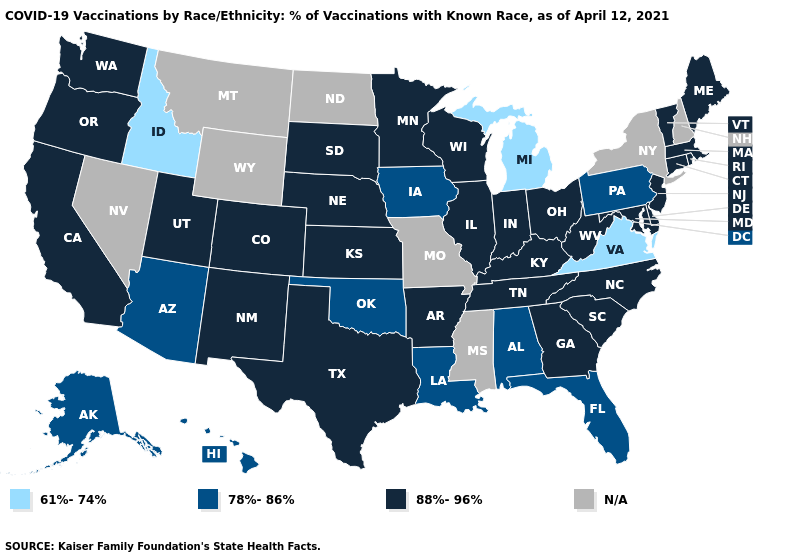Which states have the lowest value in the West?
Short answer required. Idaho. Does the map have missing data?
Keep it brief. Yes. Does Michigan have the lowest value in the MidWest?
Short answer required. Yes. Which states have the lowest value in the South?
Write a very short answer. Virginia. Name the states that have a value in the range 88%-96%?
Answer briefly. Arkansas, California, Colorado, Connecticut, Delaware, Georgia, Illinois, Indiana, Kansas, Kentucky, Maine, Maryland, Massachusetts, Minnesota, Nebraska, New Jersey, New Mexico, North Carolina, Ohio, Oregon, Rhode Island, South Carolina, South Dakota, Tennessee, Texas, Utah, Vermont, Washington, West Virginia, Wisconsin. How many symbols are there in the legend?
Write a very short answer. 4. Among the states that border New Jersey , which have the lowest value?
Keep it brief. Pennsylvania. What is the value of Massachusetts?
Answer briefly. 88%-96%. What is the highest value in states that border Vermont?
Keep it brief. 88%-96%. What is the highest value in the USA?
Quick response, please. 88%-96%. What is the highest value in the USA?
Short answer required. 88%-96%. What is the value of Kansas?
Concise answer only. 88%-96%. 